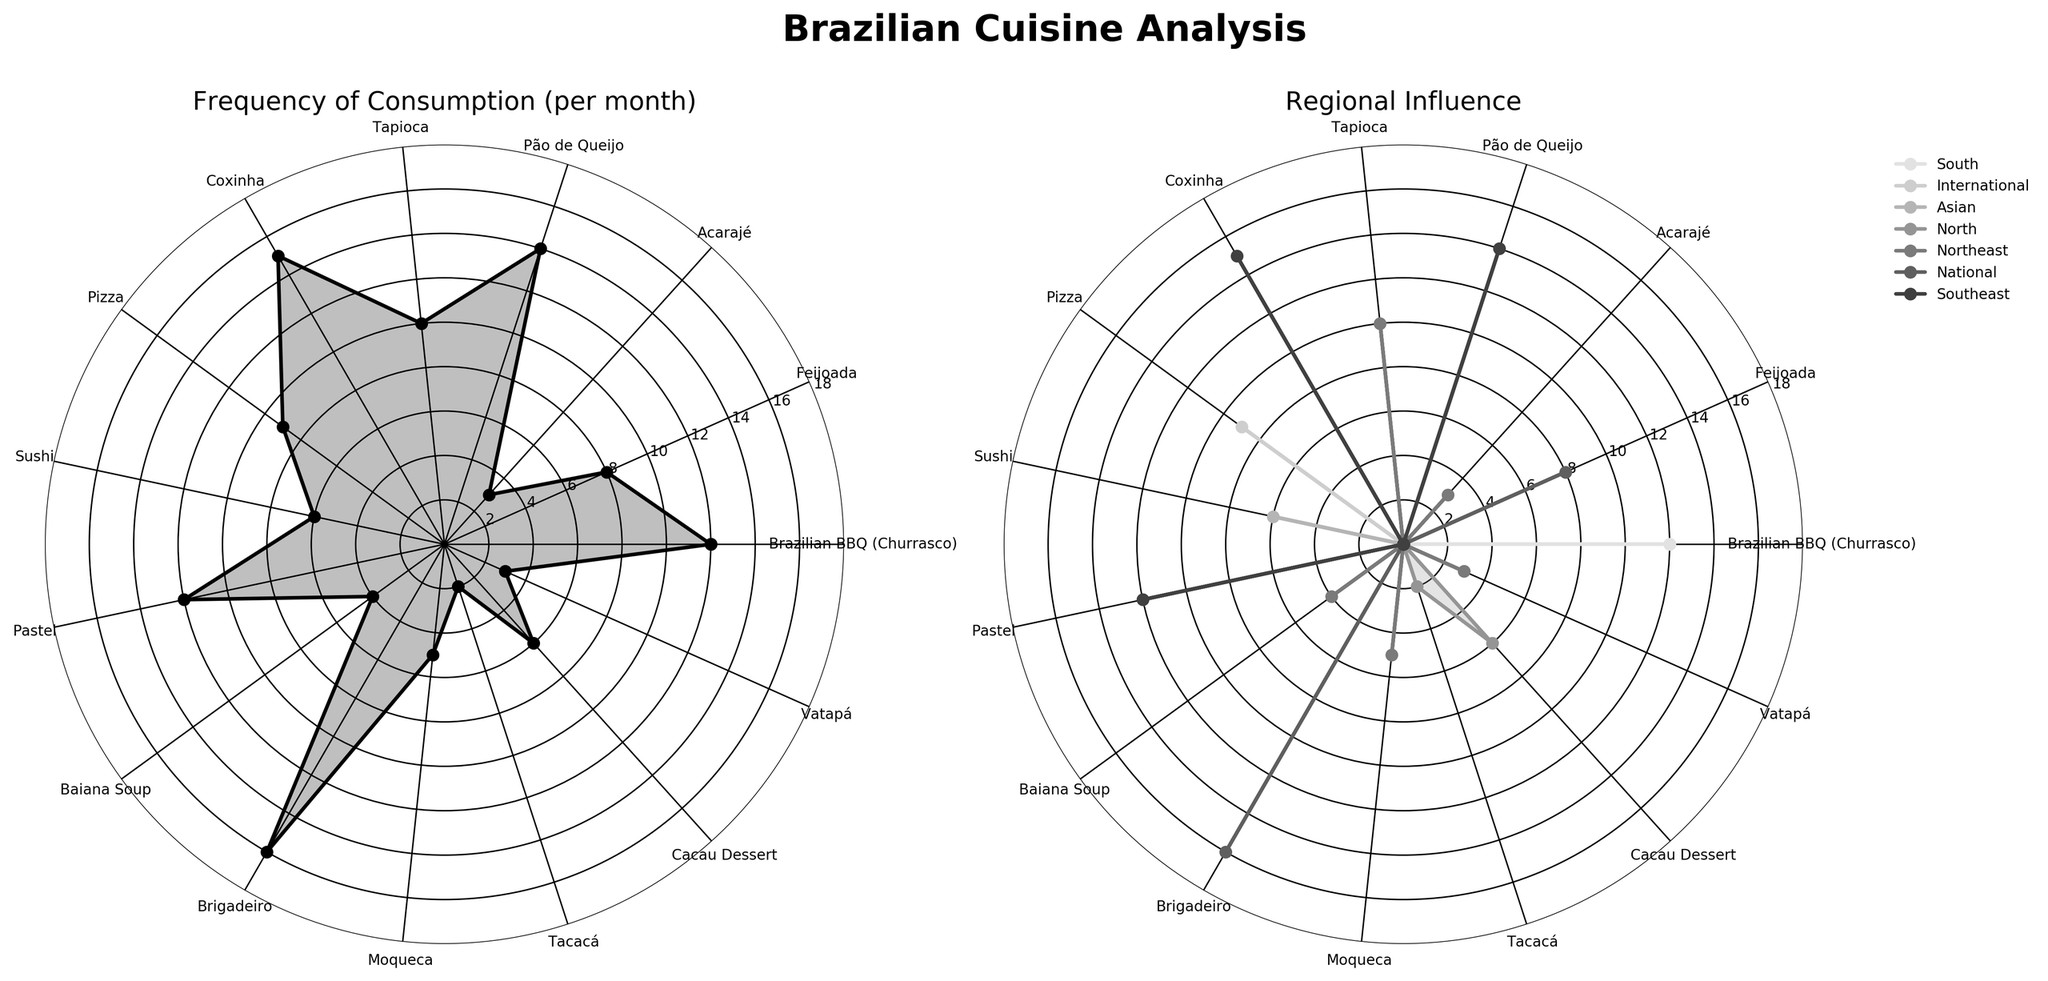What is the title of the figure? The title is usually placed at the top of the figure and helps summarize what the figure is about. In this case, the title indicates that the figure is analyzing Brazilian cuisine.
Answer: Brazilian Cuisine Analysis Which cuisine is most frequently consumed per month? In the radar chart for frequency of consumption, the highest point on the chart will show the cuisine with the highest value. Following the angles and looking at the labels will help identify this cuisine.
Answer: Brigadeiro How many regions are represented in the regional influence plot? The legend in the regional influence subplot lists the different regions. Counting the unique entries in the legend will give the number of regions.
Answer: 5 Which Southeast cuisine has the highest consumption frequency? In the subplot for frequency of consumption, observe the data points corresponding to cuisines labeled with "Southeast" influence to find the highest value.
Answer: Coxinha What is the total consumption frequency of Northeast cuisines? Identify all the Northeast cuisines in the radar chart, then sum their frequency values. Northeast cuisines are Acarajé (3), Tapioca (10), Baiana Soup (4), Moqueca (5), and Vatapá (3). Sum the corresponding frequencies.
Answer: 25 Which cuisine from São Paulo has the lowest consumption frequency? Look at the city labels and find cuisines from São Paulo, then compare their frequency values to find the lowest. The relevant cuisines are Feijoada, Coxinha, and Sushi, with frequencies 8, 15, and 6, respectively.
Answer: Sushi How does the consumption frequency of Brazilian BBQ (Churrasco) compare to Pizza? Locate the data points for both Brazilian BBQ (Churrasco) and Pizza on the frequency radar chart, then compare their values directly. Brazilian BBQ (Churrasco) has 12, while Pizza has 9.
Answer: Brazilian BBQ (Churrasco) is consumed more frequently than Pizza What is the average consumption frequency of national cuisines? Identify the national cuisines (Feijoada and Brigadeiro) and their frequencies (8 and 16). Sum these values and divide by the number of national cuisines. (8 + 16) / 2 = 24 / 2 = 12
Answer: 12 Which city is associated with the most cuisines in the dataset? Count the number of times each city appears in the city labels. The city with the highest count will be associated with the most cuisines. São Paulo appears 3 times (Feijoada, Coxinha, Sushi).
Answer: São Paulo 